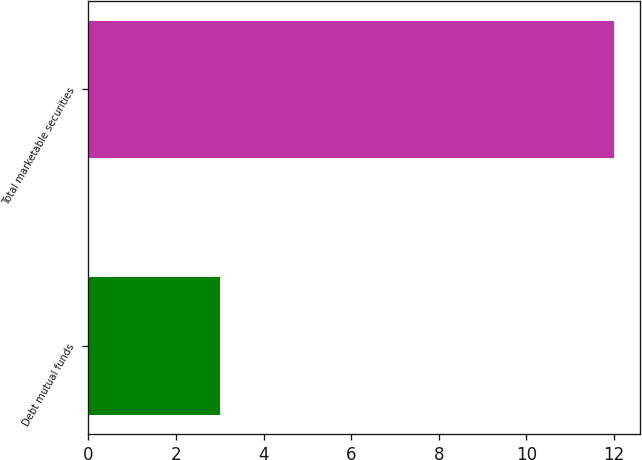Convert chart. <chart><loc_0><loc_0><loc_500><loc_500><bar_chart><fcel>Debt mutual funds<fcel>Total marketable securities<nl><fcel>3<fcel>12<nl></chart> 